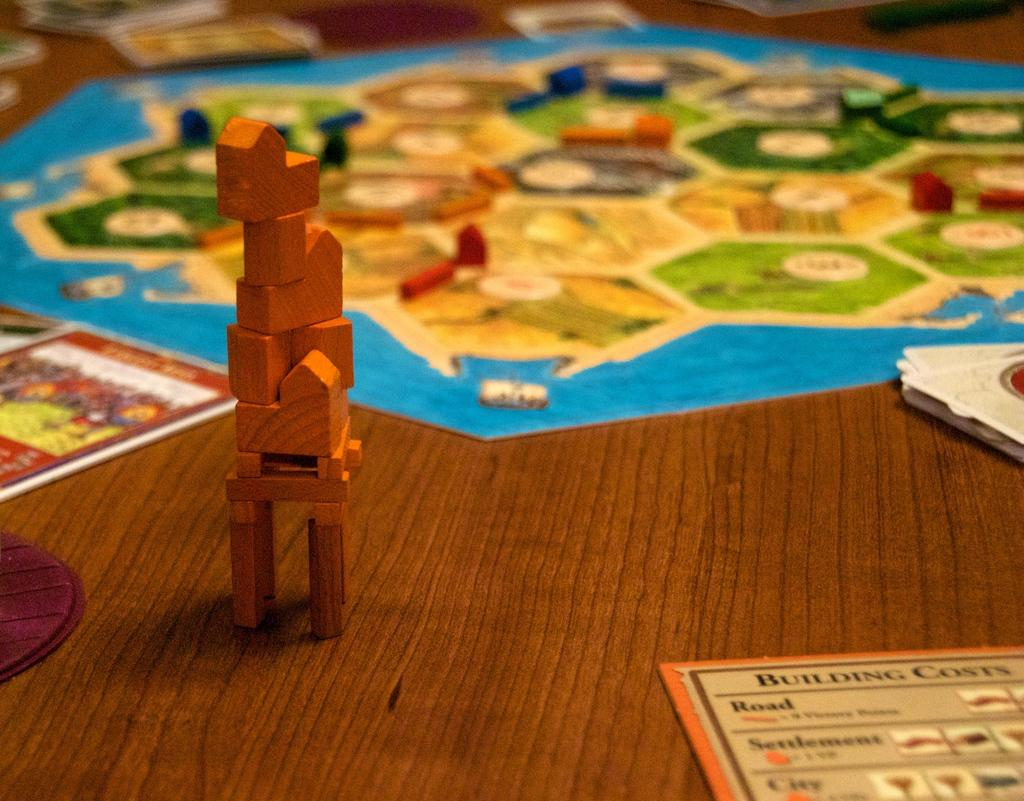<image>
Share a concise interpretation of the image provided. Settlers of Catan board game with the building costs card on the table. 